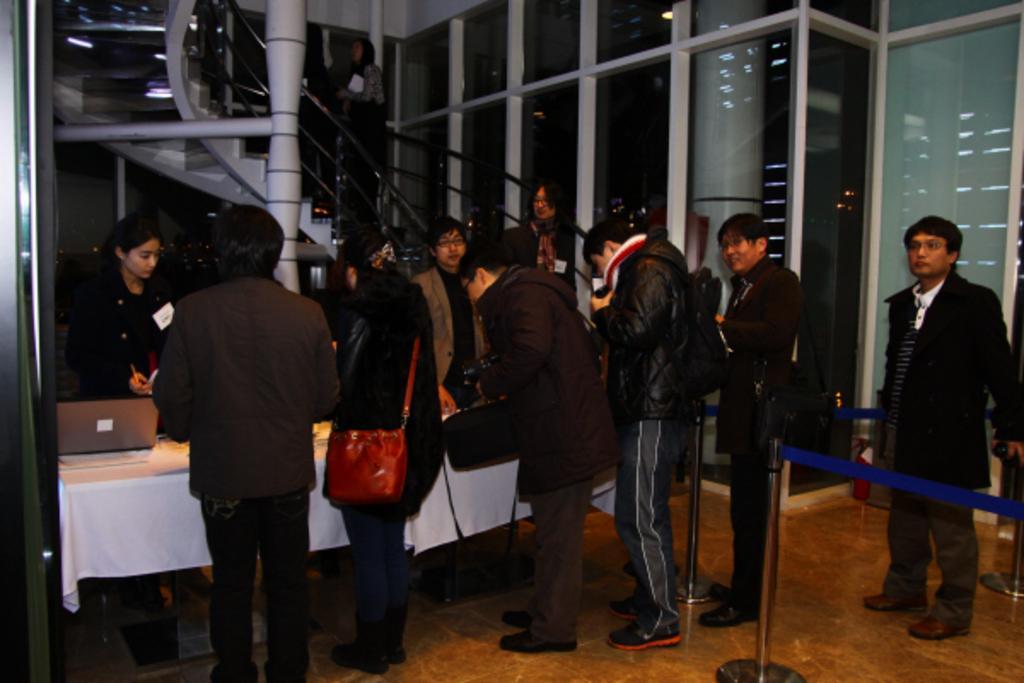In one or two sentences, can you explain what this image depicts? This image consists of few persons standing in a line. In the front, we can see a table covered with a white cloth. On which there is a laptop. In the background, we can see the stairs and a woman climbing the steps. On the right, we can see metal rods along with the ribbons. At the bottom, there is a floor. 